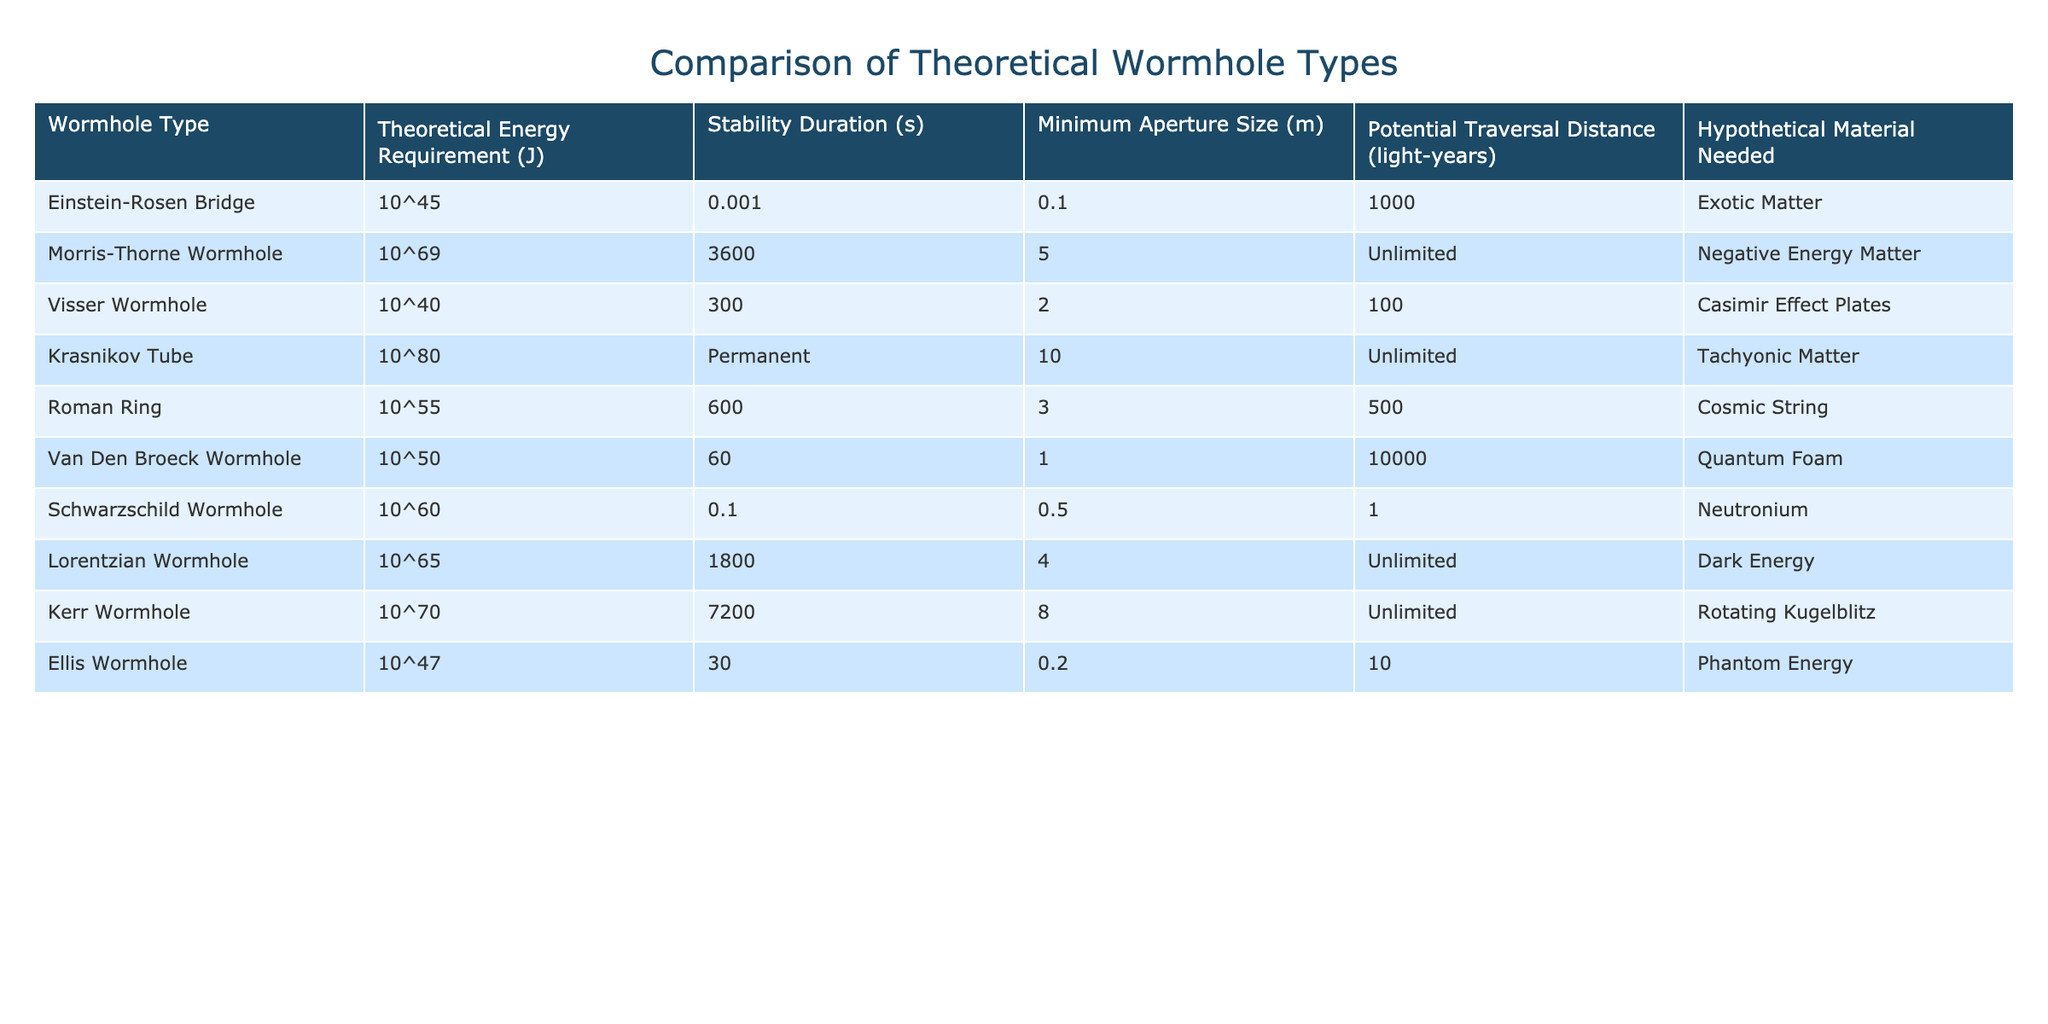What is the energy requirement for the Morris-Thorne Wormhole? The table lists the energy requirement for the Morris-Thorne Wormhole as 10^69 Joules.
Answer: 10^69 Joules Which wormhole type has the longest stability duration? According to the table, the Morris-Thorne Wormhole has the longest stability duration at 3600 seconds.
Answer: Morris-Thorne Wormhole What is the potential traversal distance of the Krasnikov Tube? The Krasnikov Tube has a potential traversal distance of unlimited light-years, as indicated in the table.
Answer: Unlimited Which wormhole requires quantum foam as its hypothetical material? The table specifies that the Van Den Broeck Wormhole requires quantum foam as its hypothetical material.
Answer: Van Den Broeck Wormhole How does the energy requirement of the Visser Wormhole compare to the Schwarzschild Wormhole? The Visser Wormhole requires 10^40 Joules, while the Schwarzschild Wormhole requires 10^60 Joules; thus, the Visser Wormhole requires significantly less energy than the Schwarzschild Wormhole.
Answer: Visser Wormhole requires less energy What is the average stability duration of the wormholes listed in the table? The stability durations are: 0.001, 3600, 300, Permanent (considered as a large value), 600, 60, 0.1, 1800, and 7200 seconds; adding these gives a sum of approximately 11070. Dividing by 9 (since there are 9 wormholes) gives an average of around 1220 seconds.
Answer: 1220 seconds Is it true that all wormholes have a minimum aperture size greater than 0.1 meters? The Ellis Wormhole has a minimum aperture size of 0.2 meters, while the Visser Wormhole has a size of 0.1 meters, which means not all wormholes exceed 0.1 meters.
Answer: No Which wormhole has both an unlimited potential traversal distance and a substantial energy requirement? The Morris-Thorne Wormhole and the Krasnikov Tube both have unlimited potential traversal distance, but the Morris-Thorne Wormhole requires 10^69 Joules, significantly less than the Krasnikov Tube's requirement of 10^80 Joules.
Answer: Morris-Thorne Wormhole If we compare the hypothetical materials needed, which wormhole requires exotic matter? The Einstein-Rosen Bridge requires exotic matter, as per the table.
Answer: Einstein-Rosen Bridge What is the difference in energy requirements between the Kerr and the Krasnikov Tube? The Kerr Wormhole requires 10^70 Joules and the Krasnikov Tube requires 10^80 Joules; thus, the difference is 10^80 - 10^70 = 9 * 10^79 Joules.
Answer: 9 * 10^79 Joules Can you list all wormholes that have a stability duration of less than one second? The only wormhole with a stability duration less than one second is the Einstein-Rosen Bridge at 0.001 seconds.
Answer: Einstein-Rosen Bridge 